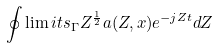Convert formula to latex. <formula><loc_0><loc_0><loc_500><loc_500>\oint \lim i t s _ { \Gamma } Z ^ { \frac { 1 } { 2 } } a ( Z , x ) e ^ { - j Z t } d Z</formula> 